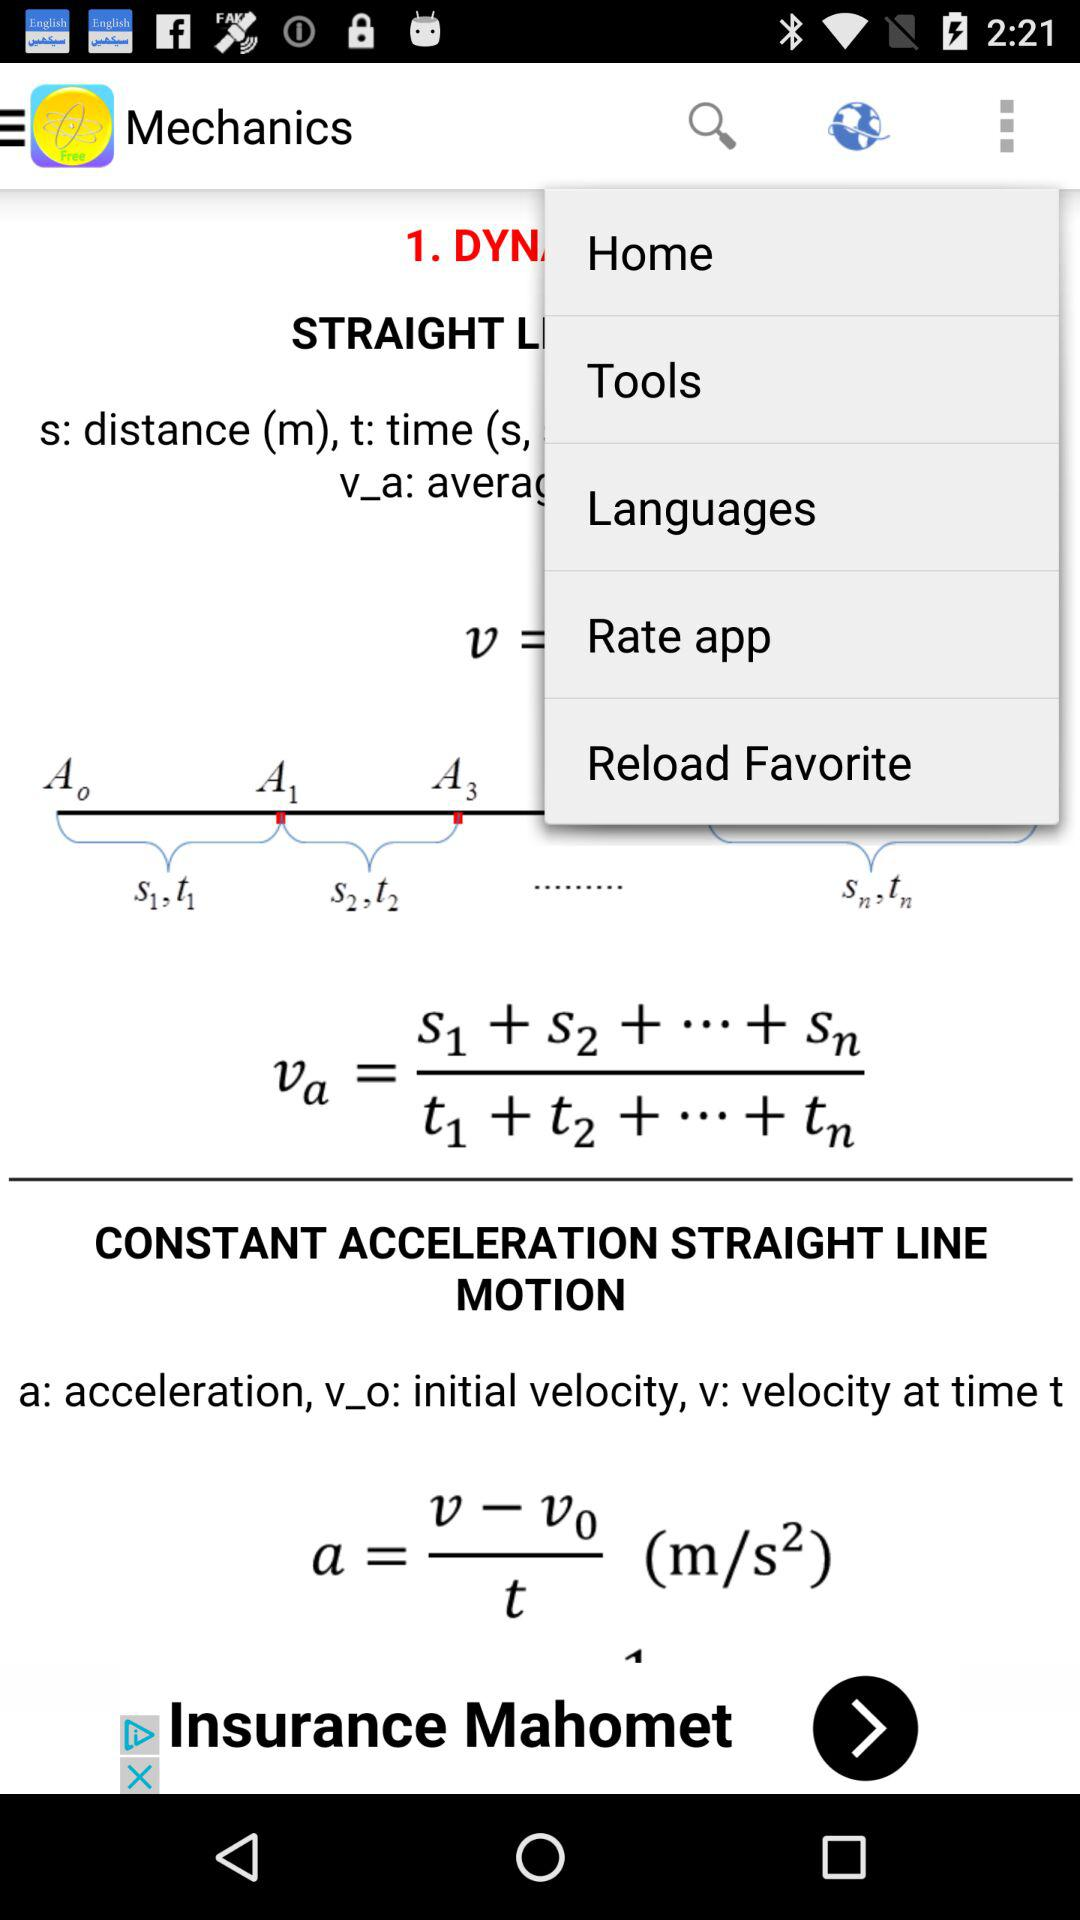What is the unit of acceleration? The unit of acceleration is metres per second square. 